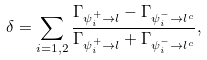<formula> <loc_0><loc_0><loc_500><loc_500>\delta = \sum _ { i = 1 , 2 } \frac { \Gamma _ { \psi _ { i } ^ { + } \rightarrow l } - \Gamma _ { \psi _ { i } ^ { - } \rightarrow l ^ { c } } } { \Gamma _ { \psi _ { i } ^ { + } \rightarrow l } + \Gamma _ { \psi _ { i } ^ { - } \rightarrow l ^ { c } } } ,</formula> 